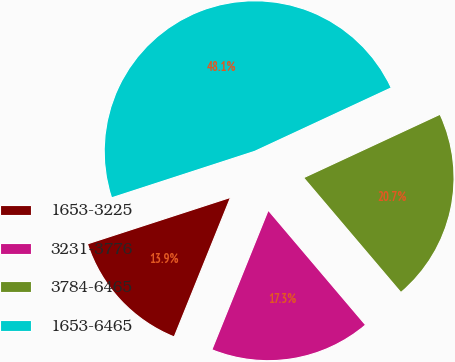Convert chart. <chart><loc_0><loc_0><loc_500><loc_500><pie_chart><fcel>1653-3225<fcel>3231-3776<fcel>3784-6465<fcel>1653-6465<nl><fcel>13.89%<fcel>17.31%<fcel>20.73%<fcel>48.08%<nl></chart> 